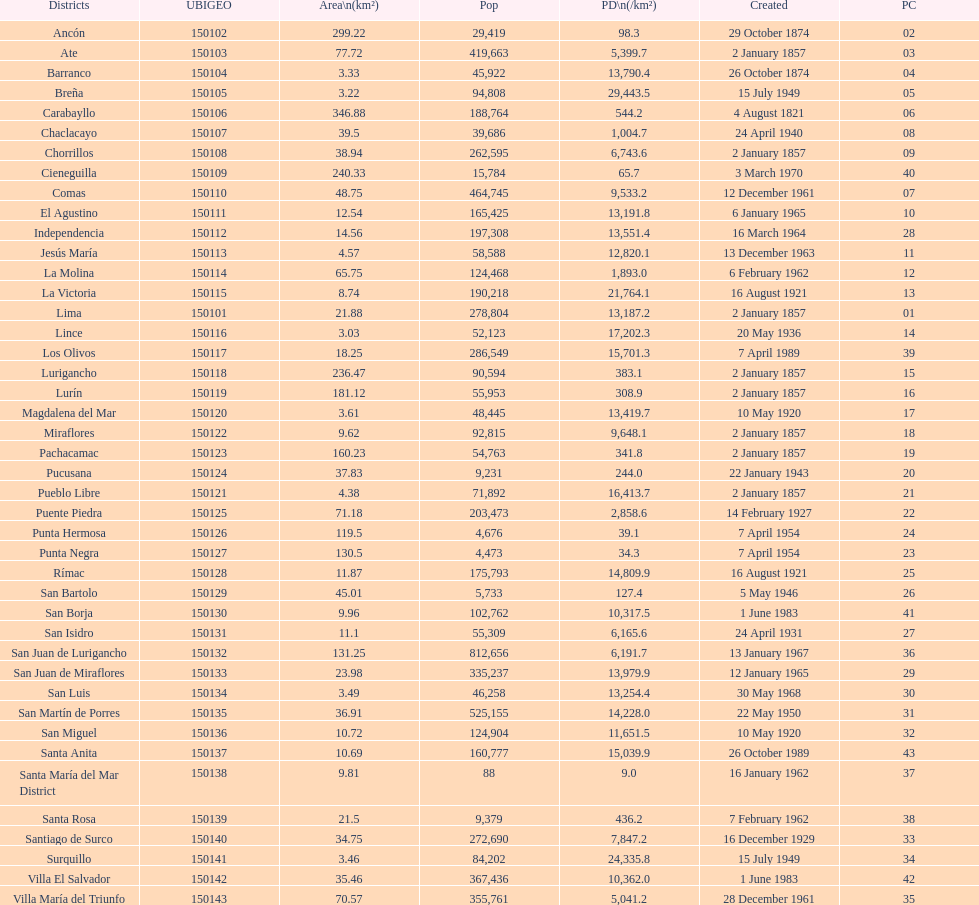Which is the largest district in terms of population? San Juan de Lurigancho. 